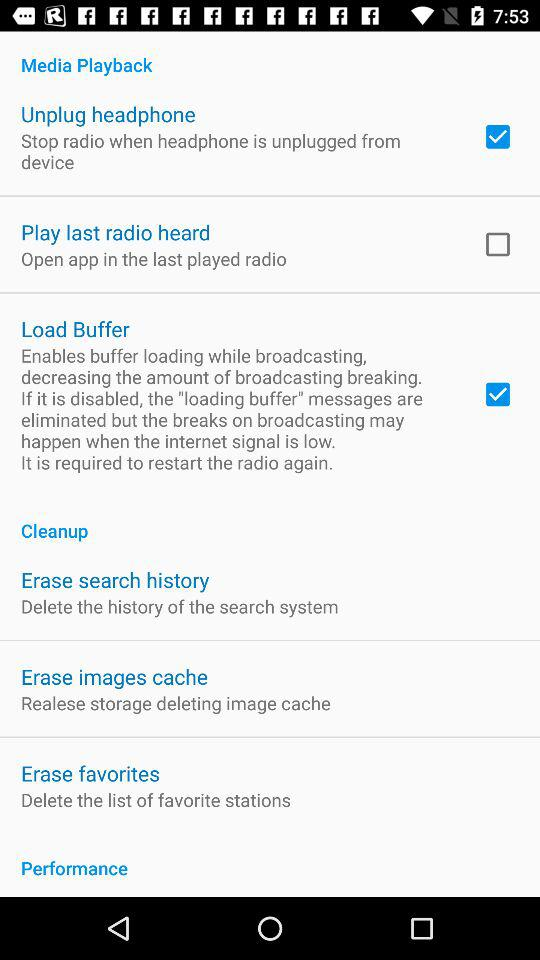Is "Play last radio heard" enabled or disabled? "Play last radio heard" is disabled. 